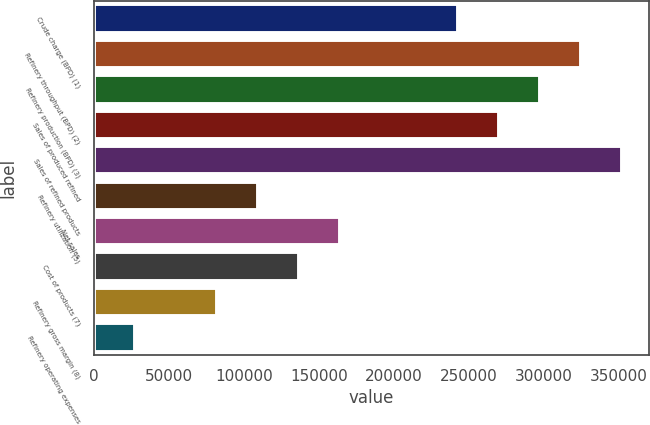Convert chart to OTSL. <chart><loc_0><loc_0><loc_500><loc_500><bar_chart><fcel>Crude charge (BPD) (1)<fcel>Refinery throughput (BPD) (2)<fcel>Refinery production (BPD) (3)<fcel>Sales of produced refined<fcel>Sales of refined products<fcel>Refinery utilization (5)<fcel>Net sales<fcel>Cost of products (7)<fcel>Refinery gross margin (8)<fcel>Refinery operating expenses<nl><fcel>243240<fcel>325327<fcel>297965<fcel>270602<fcel>352690<fcel>109455<fcel>164180<fcel>136818<fcel>82092.9<fcel>27368<nl></chart> 